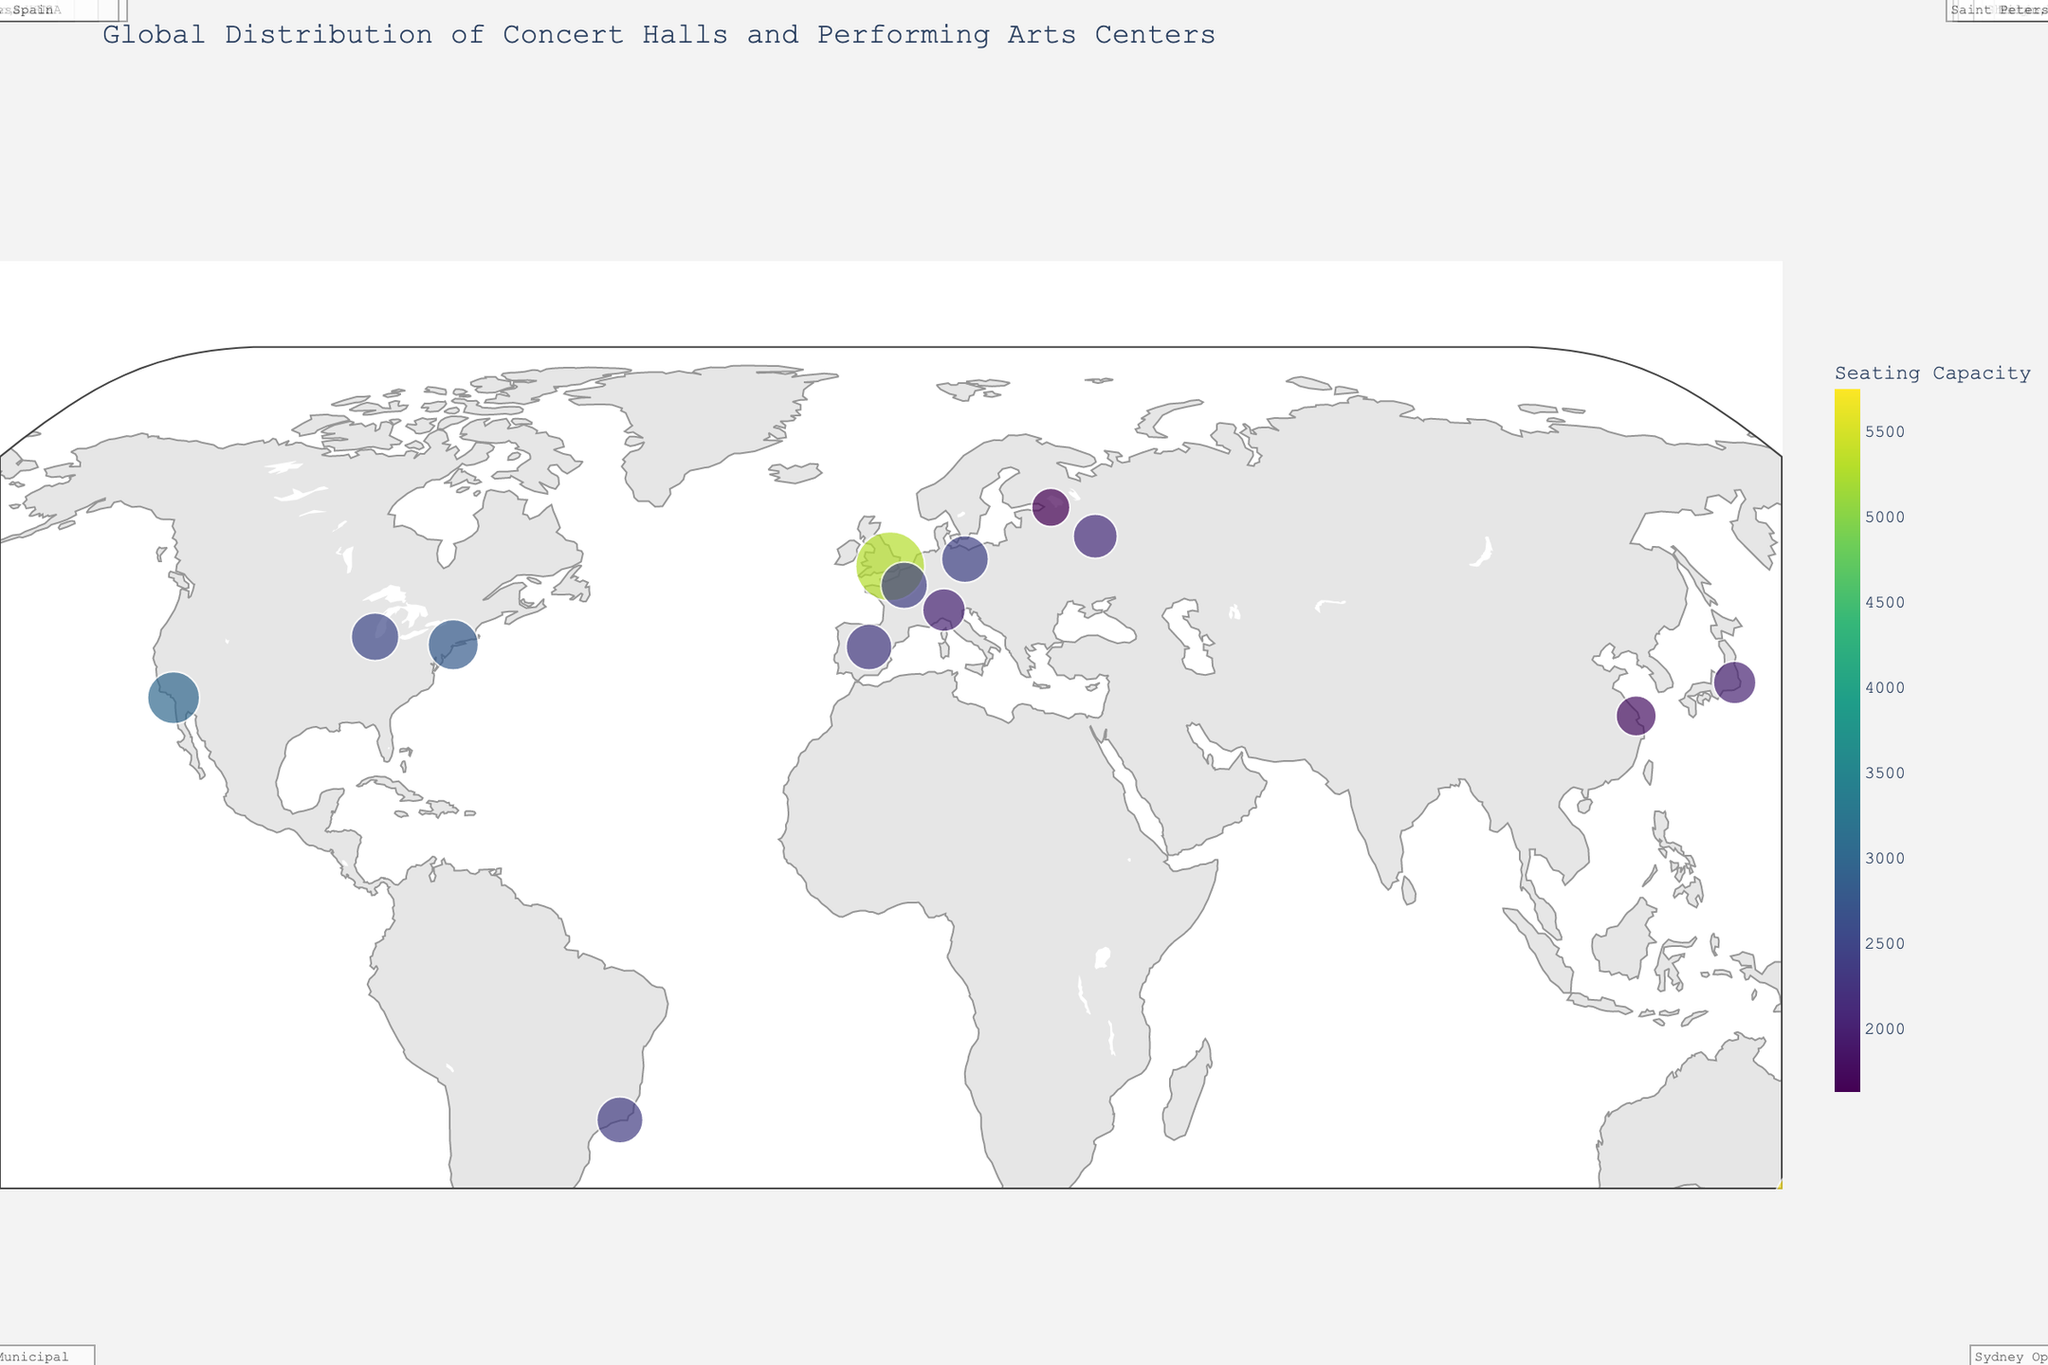What is the title of the plot? The title of the plot can be found at the top center of the figure.
Answer: Global Distribution of Concert Halls and Performing Arts Centers Which concert hall or performing arts center has the largest seating capacity? By looking at the size of the markers on the map, the Sydney Opera House has the largest seating capacity.
Answer: Sydney Opera House How many concert halls and performing arts centers are in the USA? There are three markers in the USA (New York, Chicago, and Costa Mesa) indicating the concert halls or performing arts centers.
Answer: 3 What is the seating capacity of the Bolshoi Theatre in Moscow? Hover over the point located in Moscow, Russia to see the seating capacity in the tooltip.
Answer: 2153 Which city has more than one concert hall or performing arts center marked on this map? Check the locations of the points on the map and see if any city has multiple markers.
Answer: None Which country in South America has a concert hall or performing arts center on this map? Identify the region of South America and look for one's point there; it points to Rio de Janeiro, Brazil.
Answer: Brazil How does the seating capacity of the Teatro alla Scala in Milan compare to that of the Suntory Hall in Tokyo? Locate the points for Milan and Tokyo, note their seating capacities, and compare them. Teatro alla Scala has 2030 seats, and Suntory Hall has 2006 seats, so Teatro alla Scala has more.
Answer: Teatro alla Scala has a larger seating capacity What continents do not have any concert halls or performing arts centers represented on this map? Observe the world map and see which continents do not have any markers.
Answer: Africa, Antarctica Which city has the highest concentration of concert halls and performing arts centers? Check all the markers on the map and see which city contains multiple venues. The highest concentration in a single city would be where one city has multiple markers.
Answer: None Which performing arts center in Europe has the smallest seating capacity? Review points in Europe, noting their seating capacities and identifying the smallest one.
Answer: Mariinsky Theatre, Russia 